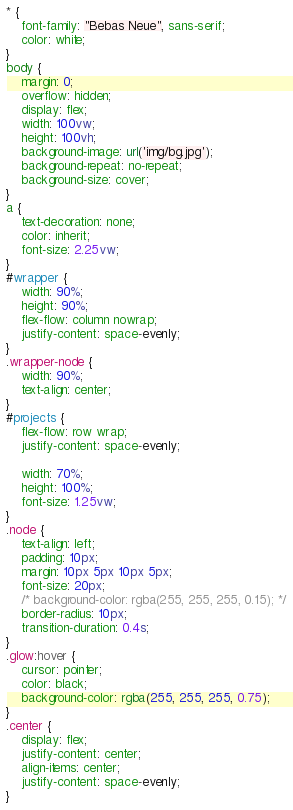Convert code to text. <code><loc_0><loc_0><loc_500><loc_500><_CSS_>* {
    font-family: "Bebas Neue", sans-serif;
    color: white;
}
body {
    margin: 0;
    overflow: hidden;
    display: flex;
    width: 100vw;
    height: 100vh;
    background-image: url('img/bg.jpg');
    background-repeat: no-repeat;
    background-size: cover;
}
a {
    text-decoration: none;
    color: inherit;
    font-size: 2.25vw;
}
#wrapper {
    width: 90%;
    height: 90%;
    flex-flow: column nowrap;
    justify-content: space-evenly;
}
.wrapper-node {
    width: 90%;
    text-align: center;
}
#projects {
    flex-flow: row wrap;
    justify-content: space-evenly;

    width: 70%;
    height: 100%;
    font-size: 1.25vw;
}
.node {
    text-align: left;
    padding: 10px;
    margin: 10px 5px 10px 5px;
    font-size: 20px;
    /* background-color: rgba(255, 255, 255, 0.15); */
    border-radius: 10px;
    transition-duration: 0.4s;
}
.glow:hover {
    cursor: pointer;
    color: black;
    background-color: rgba(255, 255, 255, 0.75);
}
.center {
    display: flex;
    justify-content: center;
    align-items: center;
    justify-content: space-evenly;
}</code> 